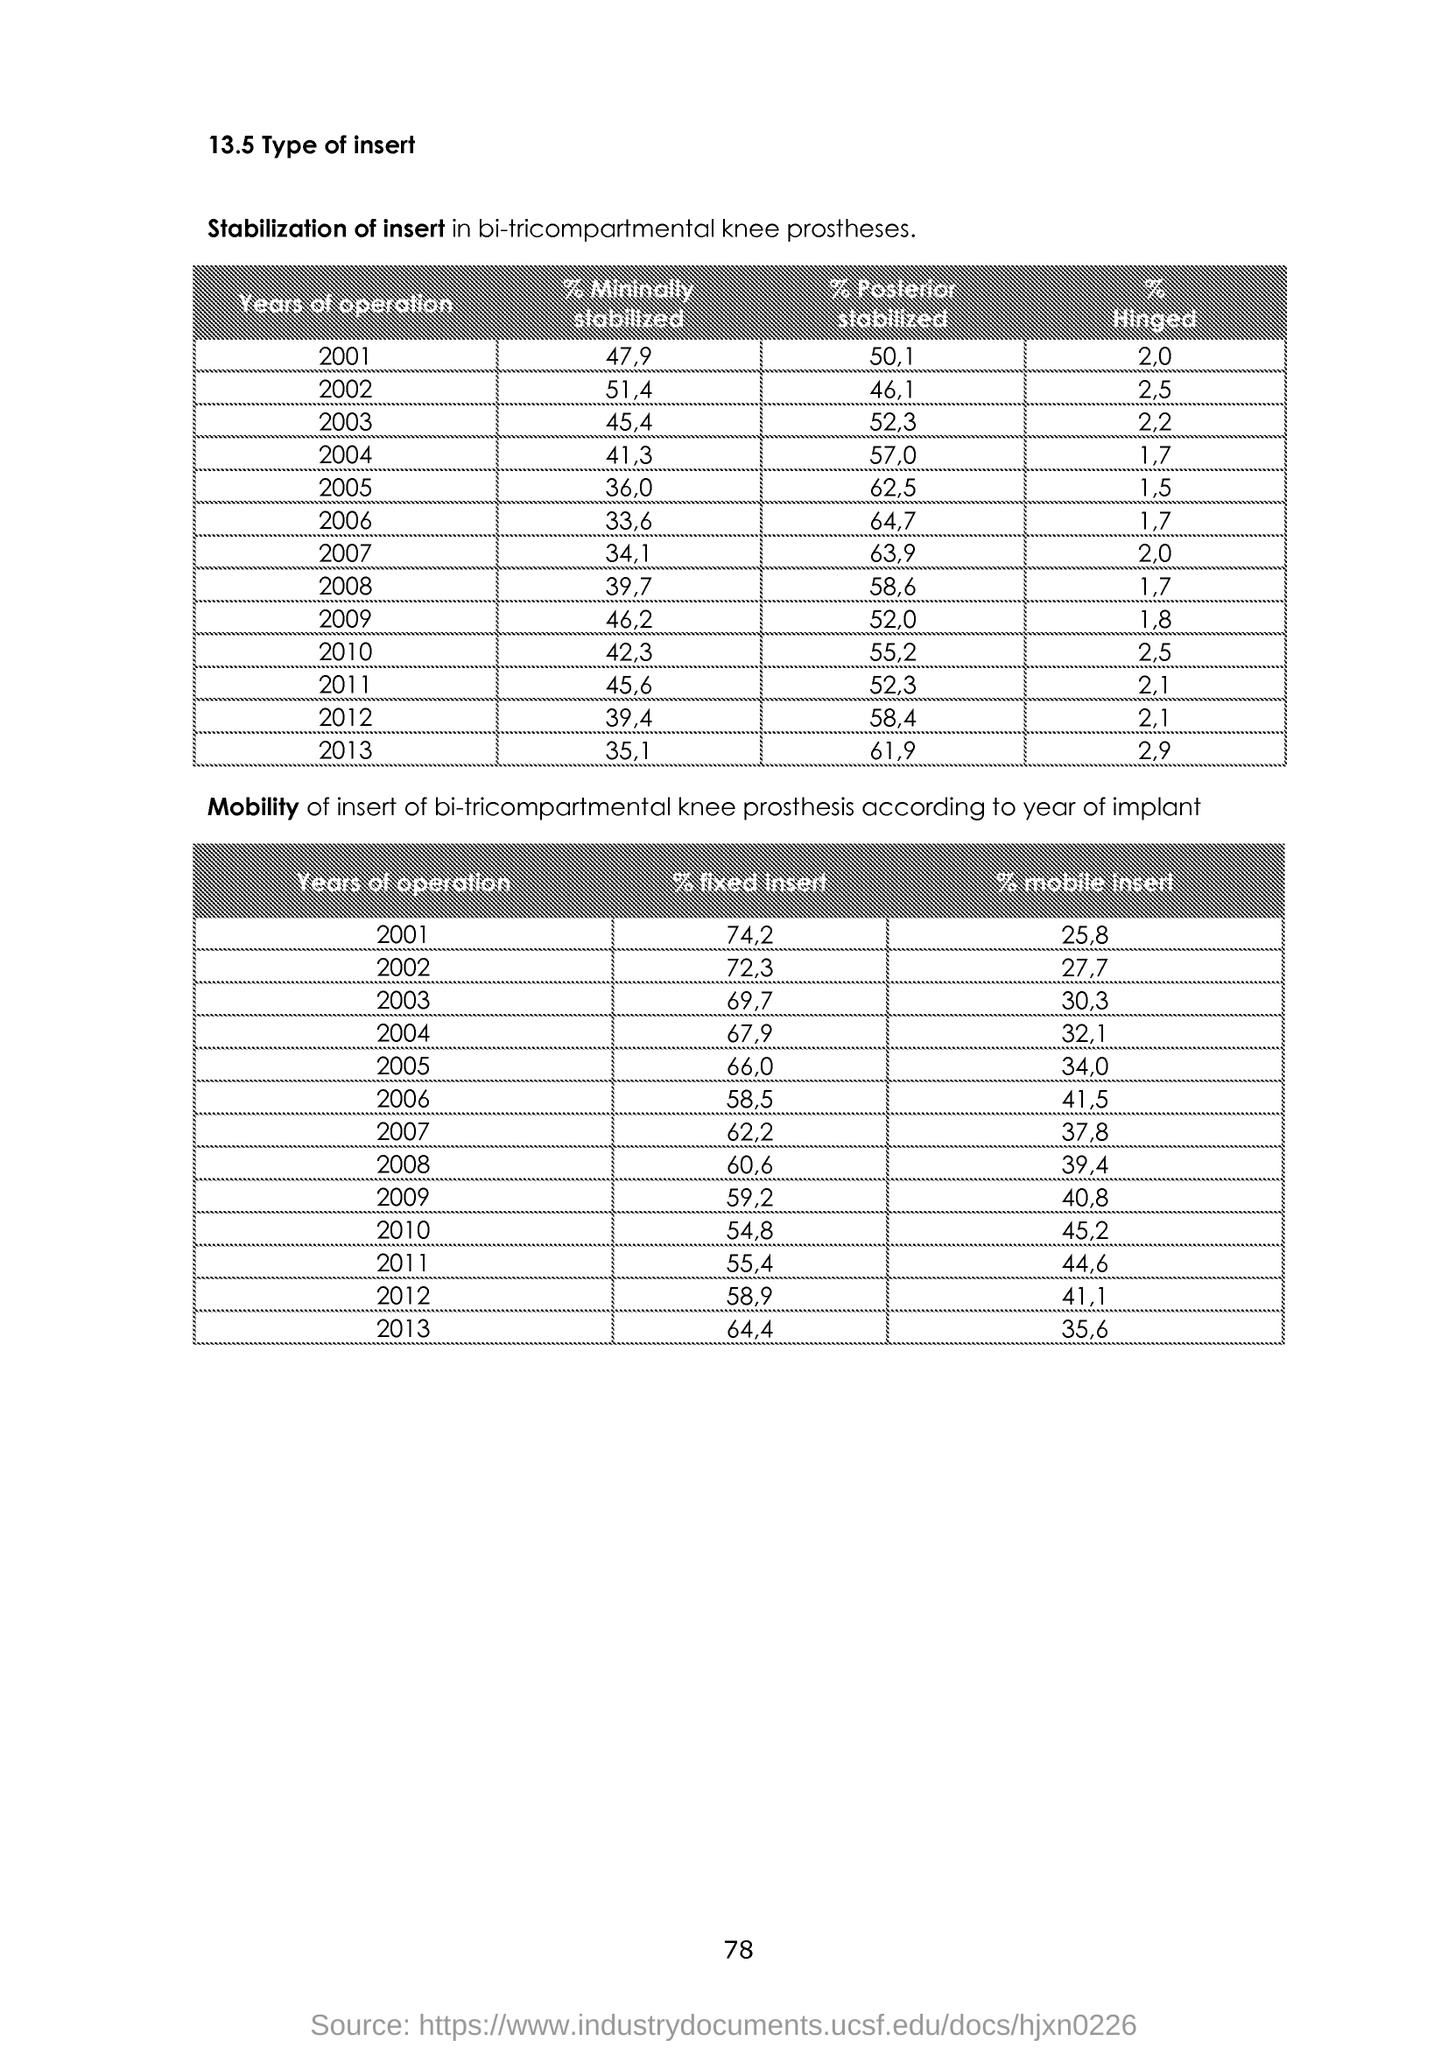Give some essential details in this illustration. The minimally stabilized percentage for 2009 is 46.2%. According to the data provided, the minimum stabilization level for 2004 was 41.3%. The minimally stabilized percentage for 2005 was 36.0%. The minimum stabilization level for 2010 was 42.3%. According to the information available, the minimum stabilized rent for 2006 was 33.6%. 